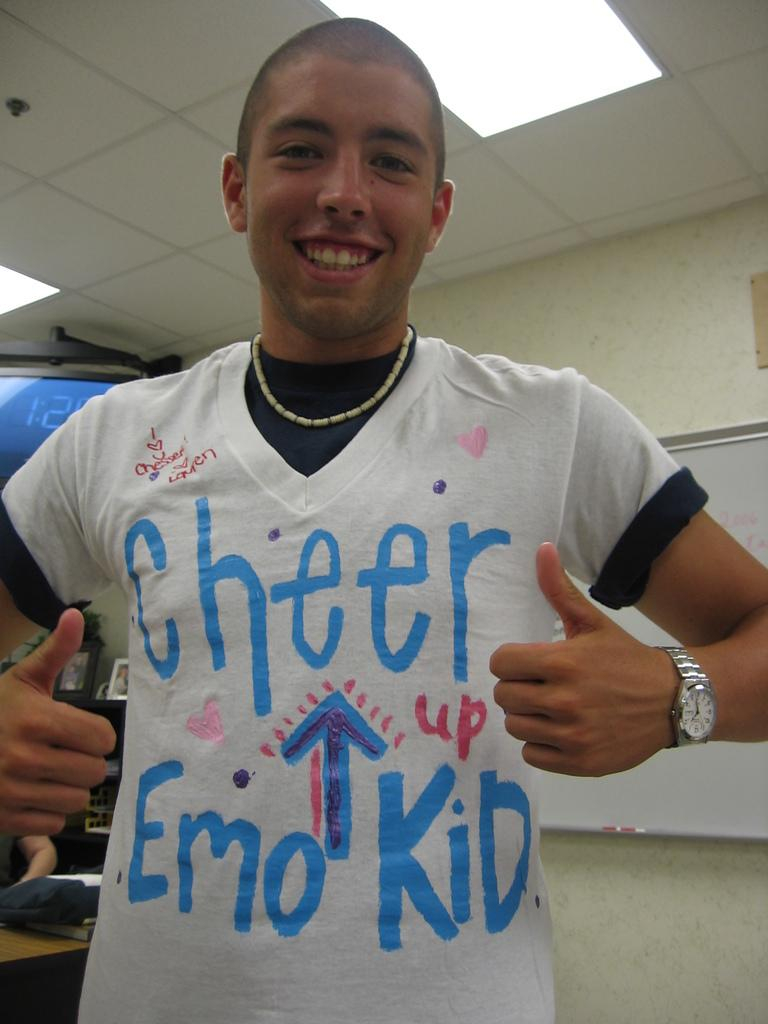Provide a one-sentence caption for the provided image. A teenager in a "Cheer Up Emo Kid" t-shirt gives a double thumbs up. 